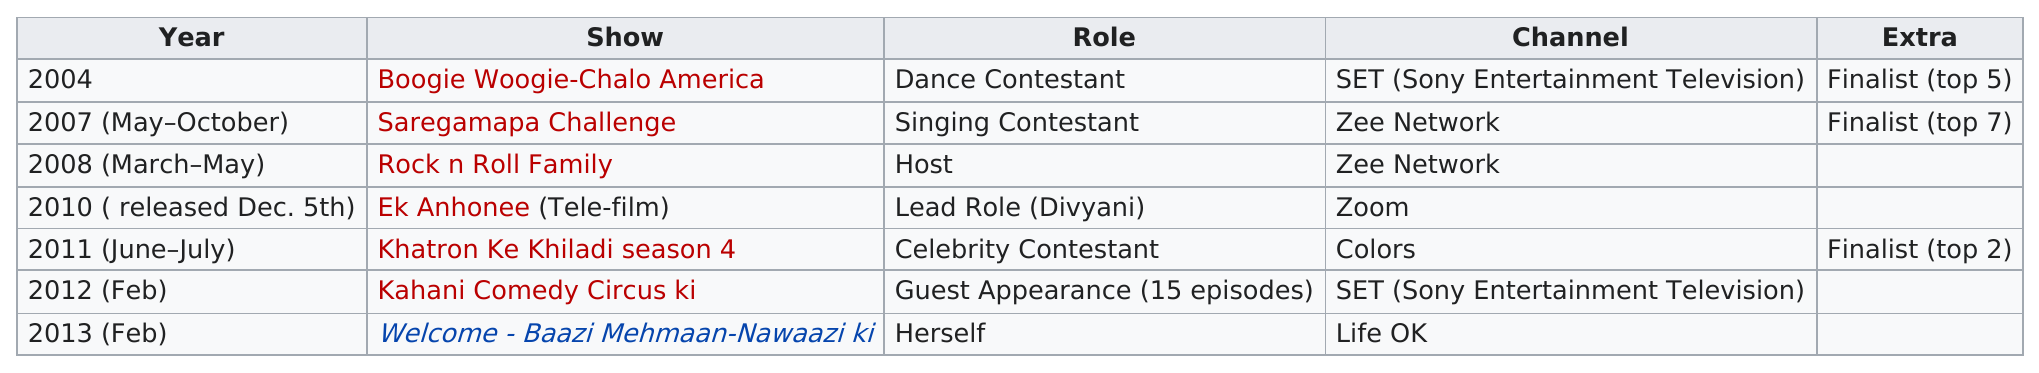Mention a couple of crucial points in this snapshot. She appeared on two shows on the Zee Network. She has appeared on a total of 5 channels. The show that aired most recently is 'Welcome - Baazi Mehmaan-Nawaazi ki...' She hosted only one show called Rock n Roll Family. The following program is listed after Ek Anhonee: Khatron Ke Khiladi season 4. 